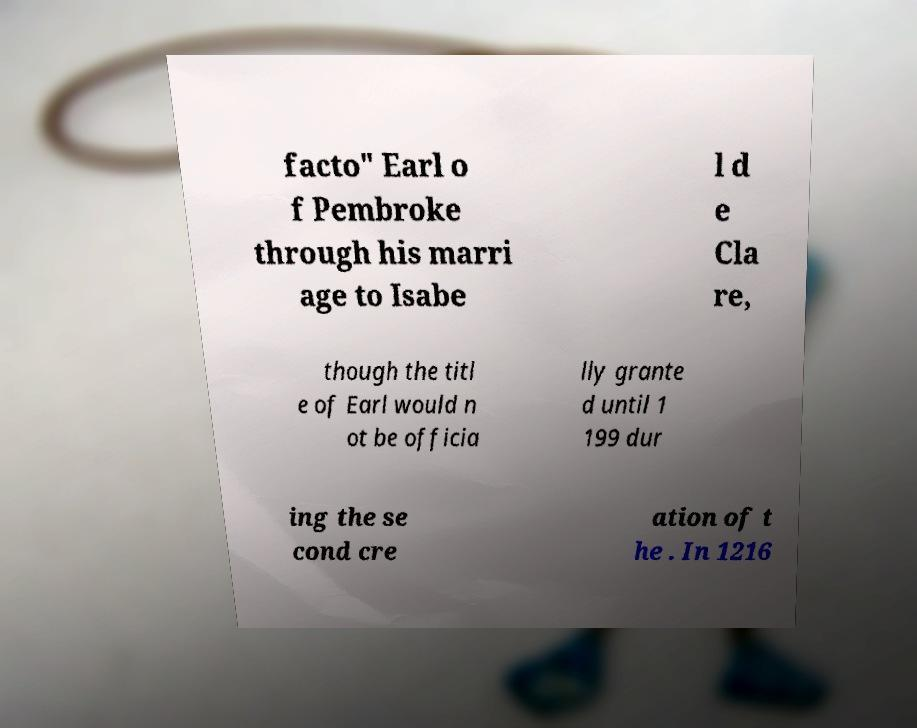Could you assist in decoding the text presented in this image and type it out clearly? facto" Earl o f Pembroke through his marri age to Isabe l d e Cla re, though the titl e of Earl would n ot be officia lly grante d until 1 199 dur ing the se cond cre ation of t he . In 1216 